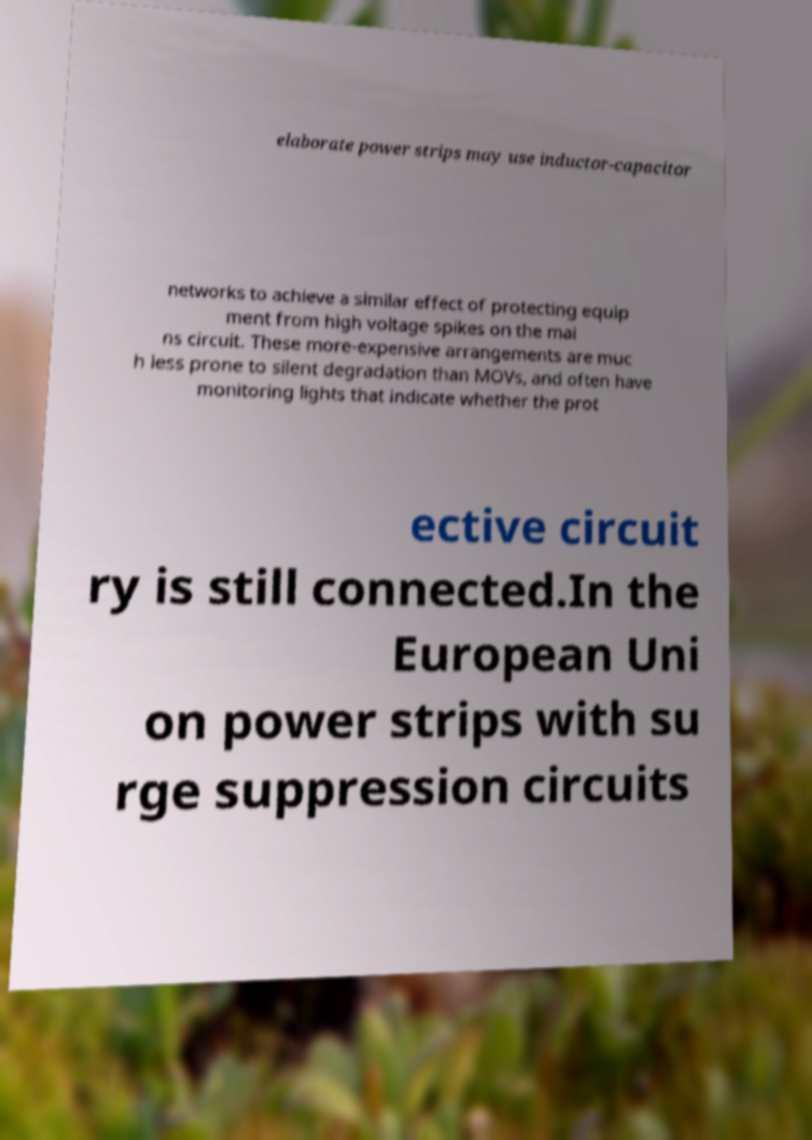Could you extract and type out the text from this image? elaborate power strips may use inductor-capacitor networks to achieve a similar effect of protecting equip ment from high voltage spikes on the mai ns circuit. These more-expensive arrangements are muc h less prone to silent degradation than MOVs, and often have monitoring lights that indicate whether the prot ective circuit ry is still connected.In the European Uni on power strips with su rge suppression circuits 